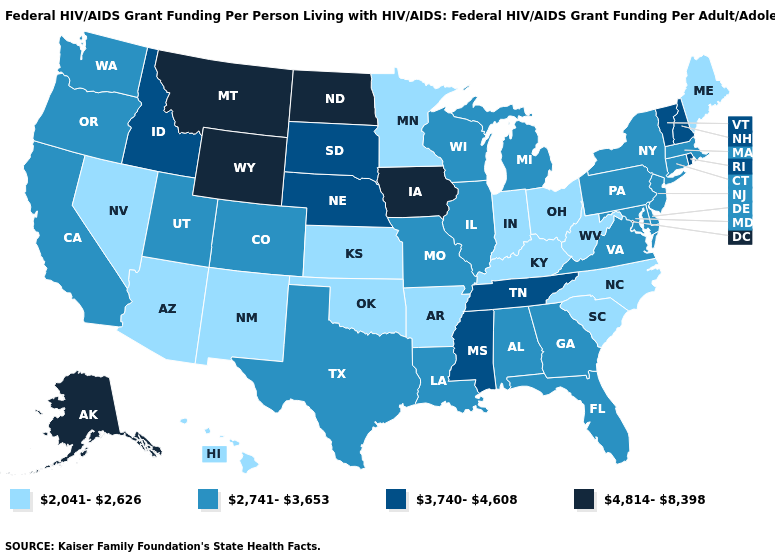What is the value of Mississippi?
Answer briefly. 3,740-4,608. What is the value of Kentucky?
Write a very short answer. 2,041-2,626. Does the map have missing data?
Quick response, please. No. What is the lowest value in the MidWest?
Short answer required. 2,041-2,626. What is the value of Minnesota?
Write a very short answer. 2,041-2,626. Name the states that have a value in the range 2,741-3,653?
Concise answer only. Alabama, California, Colorado, Connecticut, Delaware, Florida, Georgia, Illinois, Louisiana, Maryland, Massachusetts, Michigan, Missouri, New Jersey, New York, Oregon, Pennsylvania, Texas, Utah, Virginia, Washington, Wisconsin. Name the states that have a value in the range 3,740-4,608?
Short answer required. Idaho, Mississippi, Nebraska, New Hampshire, Rhode Island, South Dakota, Tennessee, Vermont. How many symbols are there in the legend?
Answer briefly. 4. What is the value of Nevada?
Concise answer only. 2,041-2,626. Name the states that have a value in the range 4,814-8,398?
Give a very brief answer. Alaska, Iowa, Montana, North Dakota, Wyoming. Which states have the lowest value in the MidWest?
Give a very brief answer. Indiana, Kansas, Minnesota, Ohio. What is the value of Kansas?
Give a very brief answer. 2,041-2,626. Name the states that have a value in the range 4,814-8,398?
Short answer required. Alaska, Iowa, Montana, North Dakota, Wyoming. Does Washington have the lowest value in the USA?
Short answer required. No. Does the map have missing data?
Short answer required. No. 